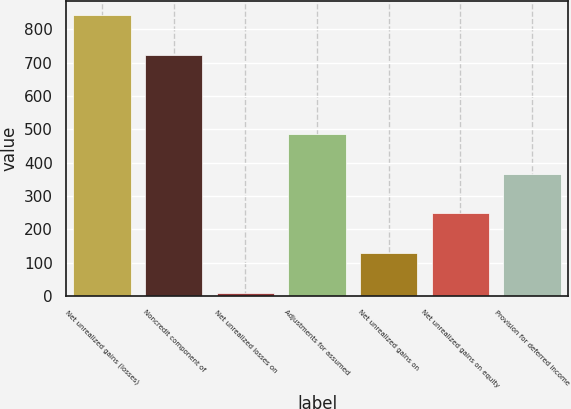Convert chart. <chart><loc_0><loc_0><loc_500><loc_500><bar_chart><fcel>Net unrealized gains (losses)<fcel>Noncredit component of<fcel>Net unrealized losses on<fcel>Adjustments for assumed<fcel>Net unrealized gains on<fcel>Net unrealized gains on equity<fcel>Provision for deferred income<nl><fcel>841.42<fcel>722.66<fcel>10.1<fcel>485.14<fcel>128.86<fcel>247.62<fcel>366.38<nl></chart> 